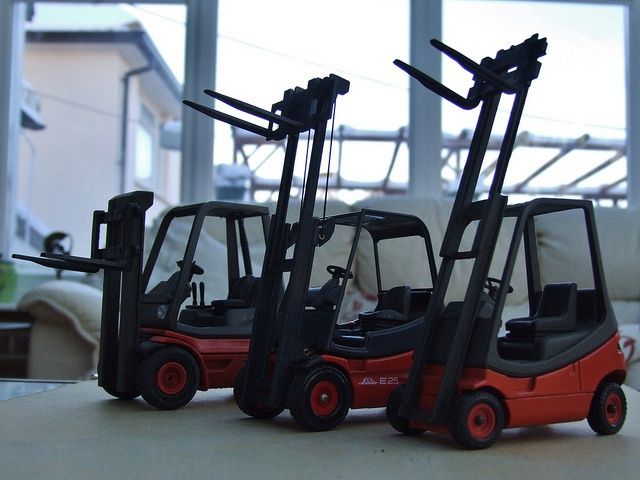Describe the objects in this image and their specific colors. I can see a couch in gray, black, and darkgray tones in this image. 